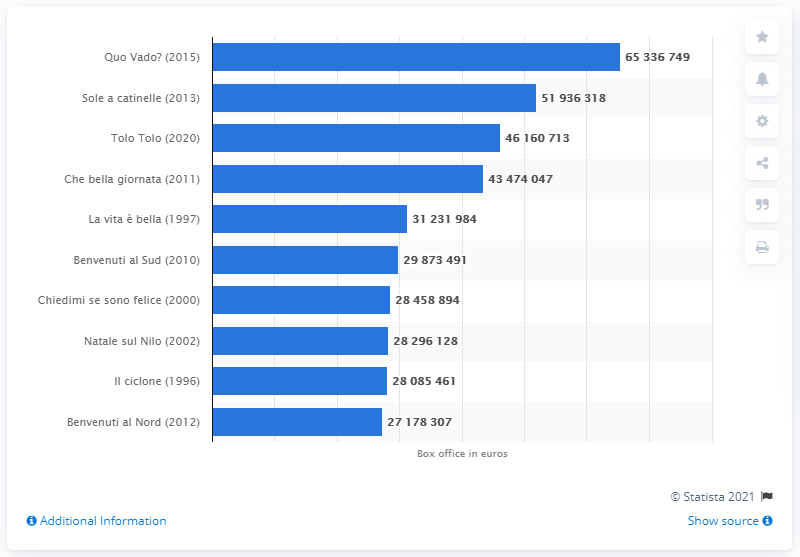Specify some key components in this picture. Quo Vado? earned approximately 653,367,490 at the box office. 